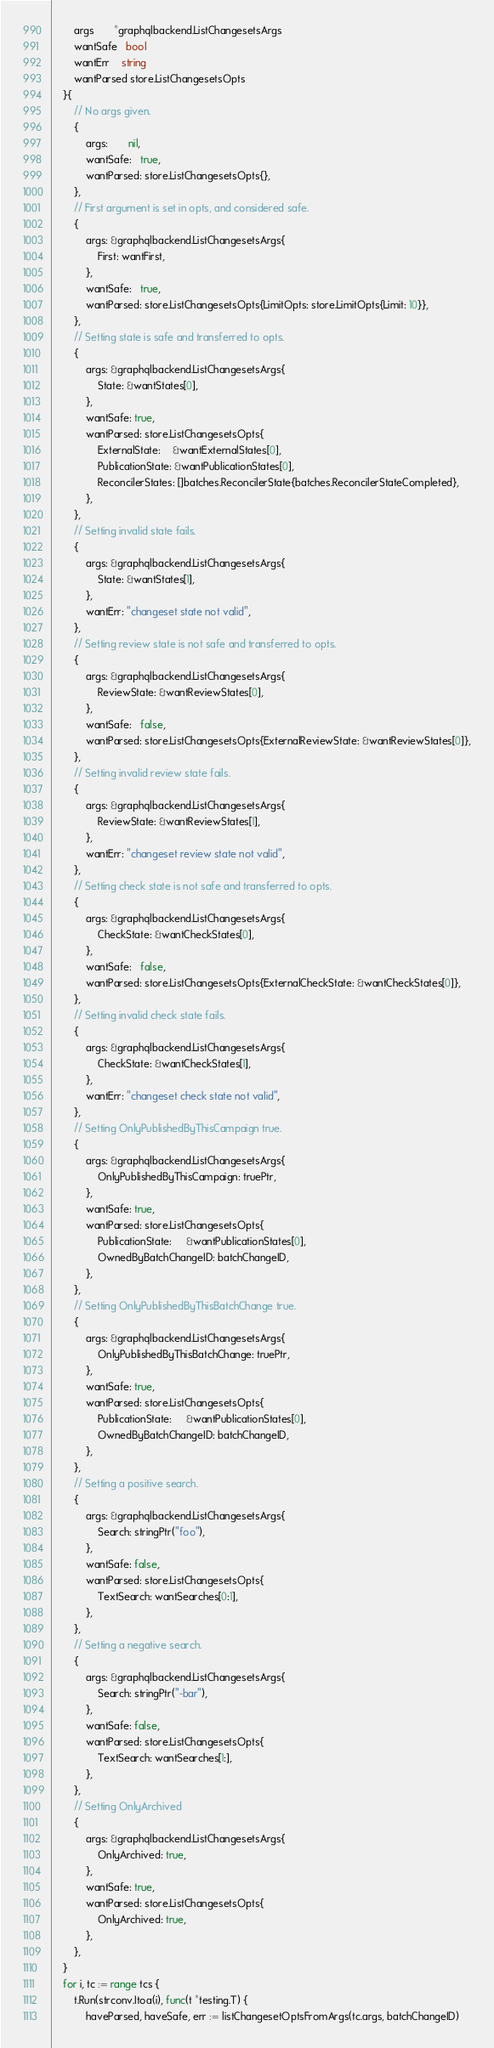<code> <loc_0><loc_0><loc_500><loc_500><_Go_>		args       *graphqlbackend.ListChangesetsArgs
		wantSafe   bool
		wantErr    string
		wantParsed store.ListChangesetsOpts
	}{
		// No args given.
		{
			args:       nil,
			wantSafe:   true,
			wantParsed: store.ListChangesetsOpts{},
		},
		// First argument is set in opts, and considered safe.
		{
			args: &graphqlbackend.ListChangesetsArgs{
				First: wantFirst,
			},
			wantSafe:   true,
			wantParsed: store.ListChangesetsOpts{LimitOpts: store.LimitOpts{Limit: 10}},
		},
		// Setting state is safe and transferred to opts.
		{
			args: &graphqlbackend.ListChangesetsArgs{
				State: &wantStates[0],
			},
			wantSafe: true,
			wantParsed: store.ListChangesetsOpts{
				ExternalState:    &wantExternalStates[0],
				PublicationState: &wantPublicationStates[0],
				ReconcilerStates: []batches.ReconcilerState{batches.ReconcilerStateCompleted},
			},
		},
		// Setting invalid state fails.
		{
			args: &graphqlbackend.ListChangesetsArgs{
				State: &wantStates[1],
			},
			wantErr: "changeset state not valid",
		},
		// Setting review state is not safe and transferred to opts.
		{
			args: &graphqlbackend.ListChangesetsArgs{
				ReviewState: &wantReviewStates[0],
			},
			wantSafe:   false,
			wantParsed: store.ListChangesetsOpts{ExternalReviewState: &wantReviewStates[0]},
		},
		// Setting invalid review state fails.
		{
			args: &graphqlbackend.ListChangesetsArgs{
				ReviewState: &wantReviewStates[1],
			},
			wantErr: "changeset review state not valid",
		},
		// Setting check state is not safe and transferred to opts.
		{
			args: &graphqlbackend.ListChangesetsArgs{
				CheckState: &wantCheckStates[0],
			},
			wantSafe:   false,
			wantParsed: store.ListChangesetsOpts{ExternalCheckState: &wantCheckStates[0]},
		},
		// Setting invalid check state fails.
		{
			args: &graphqlbackend.ListChangesetsArgs{
				CheckState: &wantCheckStates[1],
			},
			wantErr: "changeset check state not valid",
		},
		// Setting OnlyPublishedByThisCampaign true.
		{
			args: &graphqlbackend.ListChangesetsArgs{
				OnlyPublishedByThisCampaign: truePtr,
			},
			wantSafe: true,
			wantParsed: store.ListChangesetsOpts{
				PublicationState:     &wantPublicationStates[0],
				OwnedByBatchChangeID: batchChangeID,
			},
		},
		// Setting OnlyPublishedByThisBatchChange true.
		{
			args: &graphqlbackend.ListChangesetsArgs{
				OnlyPublishedByThisBatchChange: truePtr,
			},
			wantSafe: true,
			wantParsed: store.ListChangesetsOpts{
				PublicationState:     &wantPublicationStates[0],
				OwnedByBatchChangeID: batchChangeID,
			},
		},
		// Setting a positive search.
		{
			args: &graphqlbackend.ListChangesetsArgs{
				Search: stringPtr("foo"),
			},
			wantSafe: false,
			wantParsed: store.ListChangesetsOpts{
				TextSearch: wantSearches[0:1],
			},
		},
		// Setting a negative search.
		{
			args: &graphqlbackend.ListChangesetsArgs{
				Search: stringPtr("-bar"),
			},
			wantSafe: false,
			wantParsed: store.ListChangesetsOpts{
				TextSearch: wantSearches[1:],
			},
		},
		// Setting OnlyArchived
		{
			args: &graphqlbackend.ListChangesetsArgs{
				OnlyArchived: true,
			},
			wantSafe: true,
			wantParsed: store.ListChangesetsOpts{
				OnlyArchived: true,
			},
		},
	}
	for i, tc := range tcs {
		t.Run(strconv.Itoa(i), func(t *testing.T) {
			haveParsed, haveSafe, err := listChangesetOptsFromArgs(tc.args, batchChangeID)</code> 